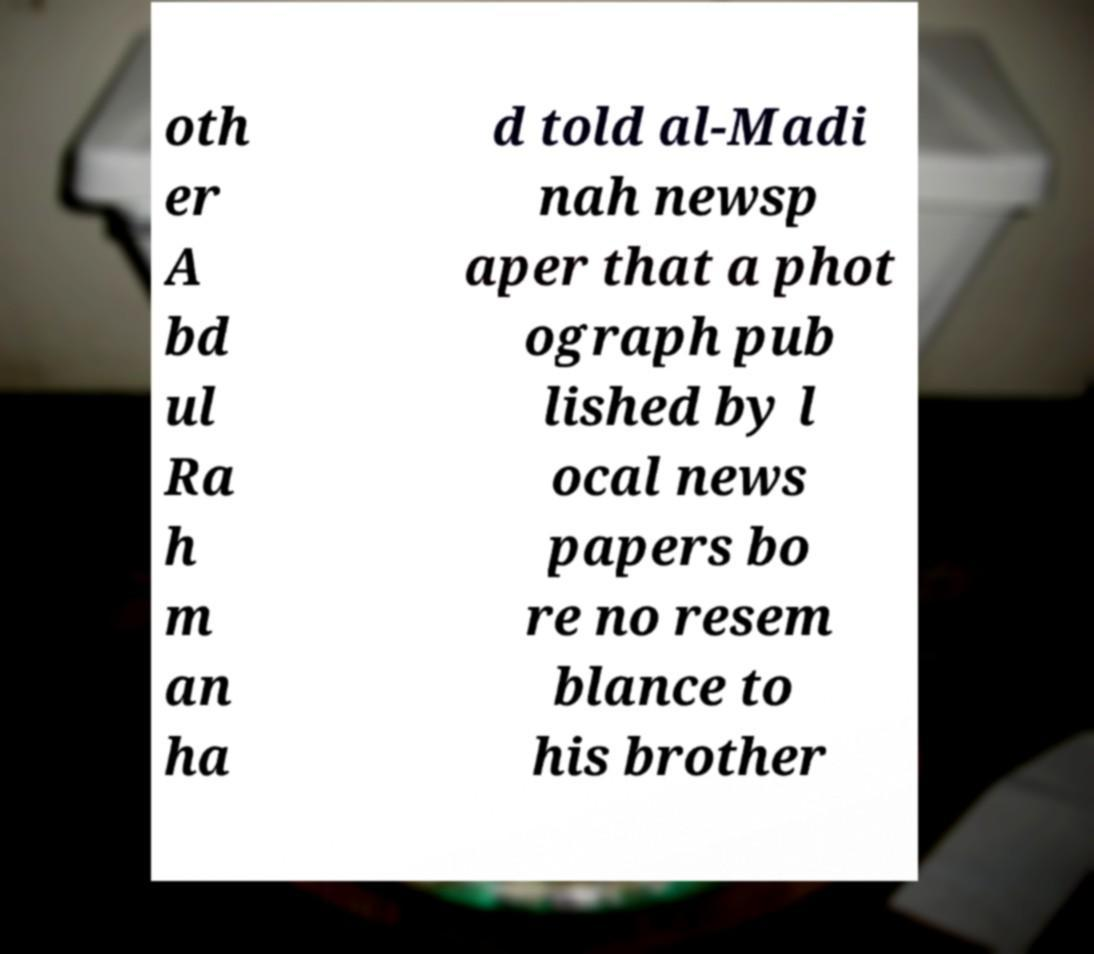Can you read and provide the text displayed in the image?This photo seems to have some interesting text. Can you extract and type it out for me? oth er A bd ul Ra h m an ha d told al-Madi nah newsp aper that a phot ograph pub lished by l ocal news papers bo re no resem blance to his brother 